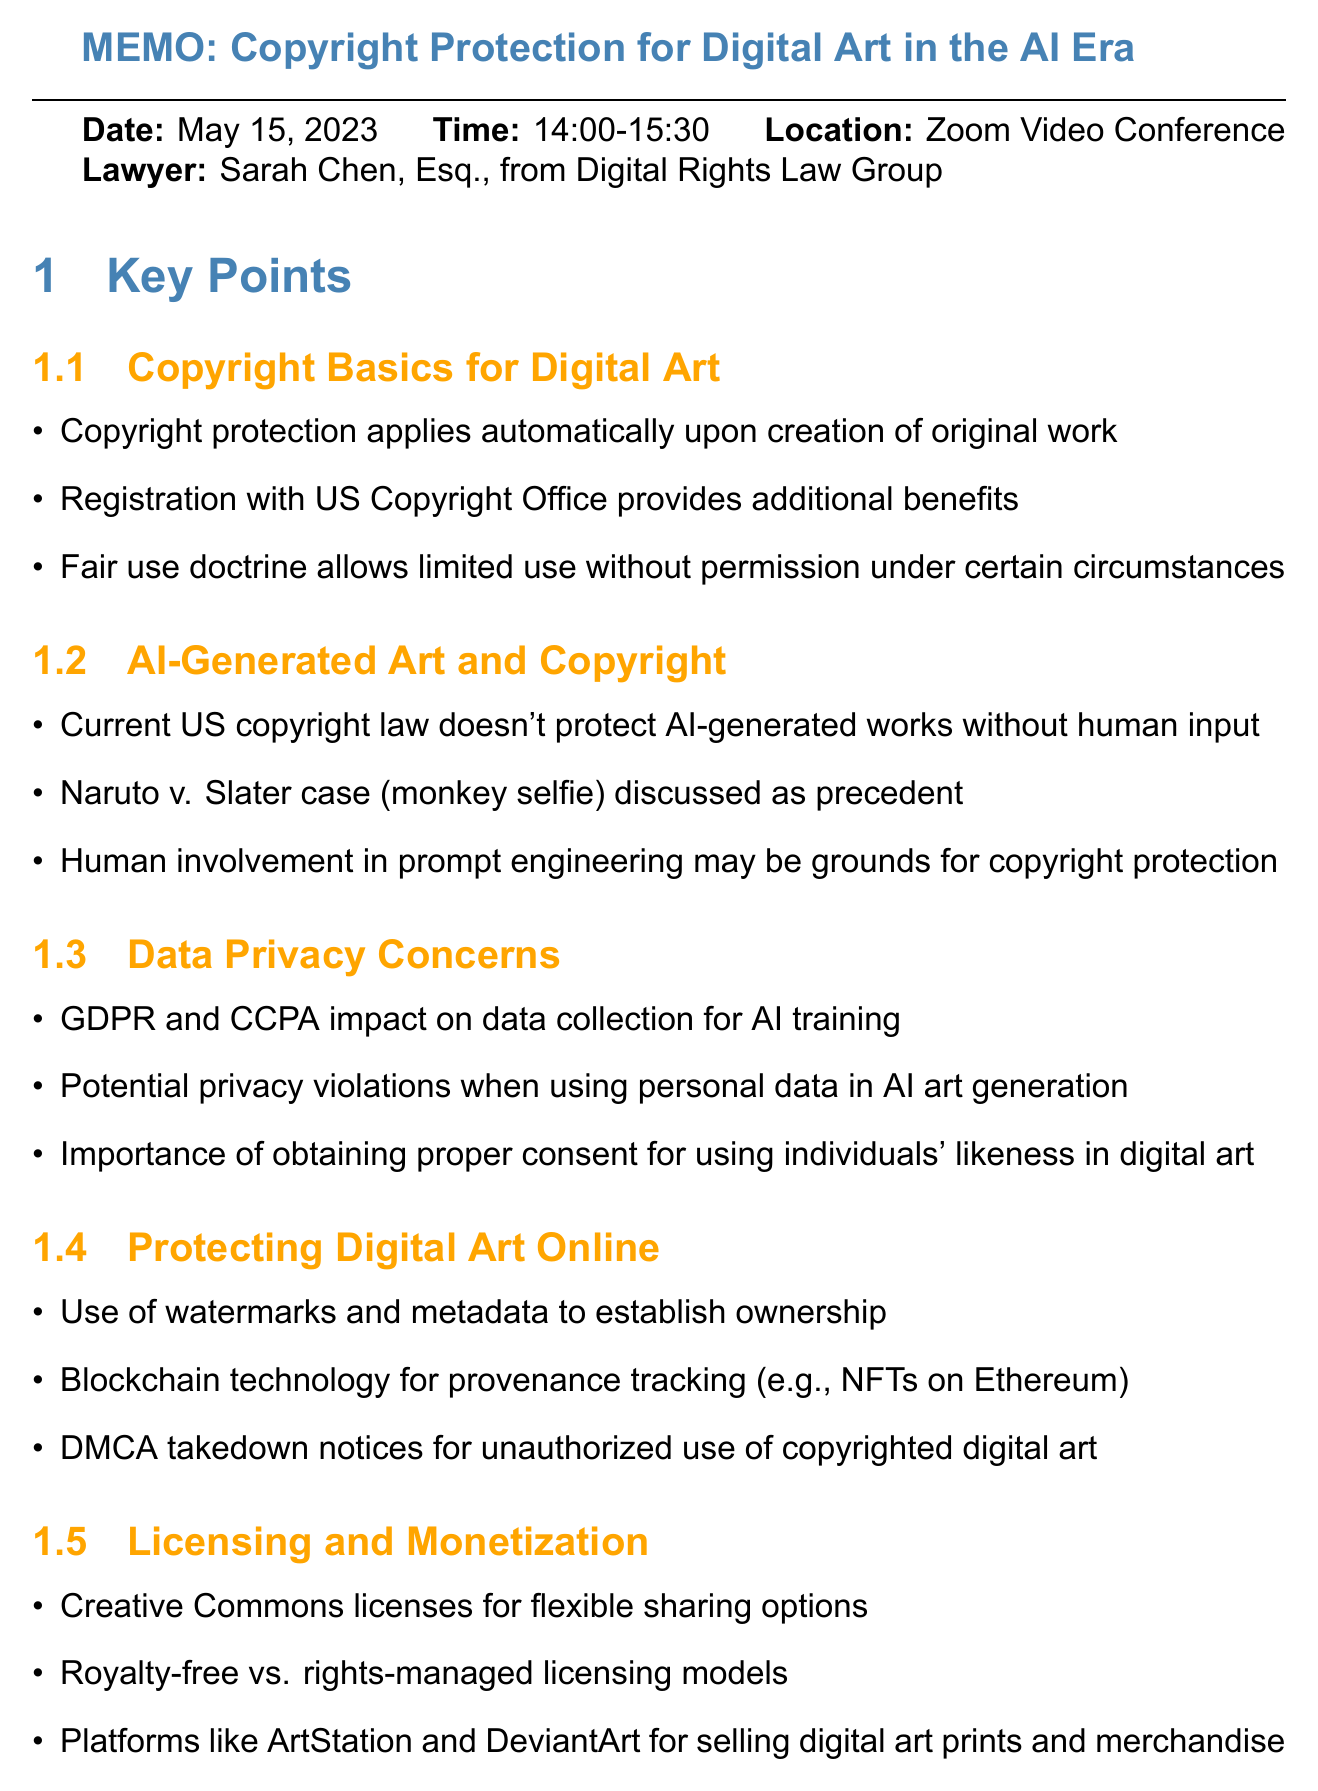What is the date of the meeting? The date of the meeting is stated clearly in the document as May 15, 2023.
Answer: May 15, 2023 Who is the lawyer mentioned in the meeting? The lawyer's name is provided in the document, specifically Sarah Chen, Esq.
Answer: Sarah Chen, Esq What is one method suggested for protecting digital art online? The document lists watermarks as a method for establishing ownership of digital art.
Answer: Watermarks Which licenses are mentioned for flexible sharing options? Creative Commons licenses are noted in the document as options for flexible sharing.
Answer: Creative Commons licenses What legal doctrine allows limited use without permission? The fair use doctrine is referenced in the document regarding limited use without permission.
Answer: Fair use doctrine How long was the meeting scheduled for? The duration of the meeting is indicated in the document as 1 hour and 30 minutes.
Answer: 1 hour and 30 minutes What technology is suggested for provenance tracking? The document mentions blockchain technology for tracking the provenance of digital art.
Answer: Blockchain technology What compliance regulations should be reviewed according to the action items? The document specifies GDPR and CCPA compliance as regulations to review in the action items.
Answer: GDPR and CCPA 